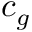Convert formula to latex. <formula><loc_0><loc_0><loc_500><loc_500>c _ { g }</formula> 